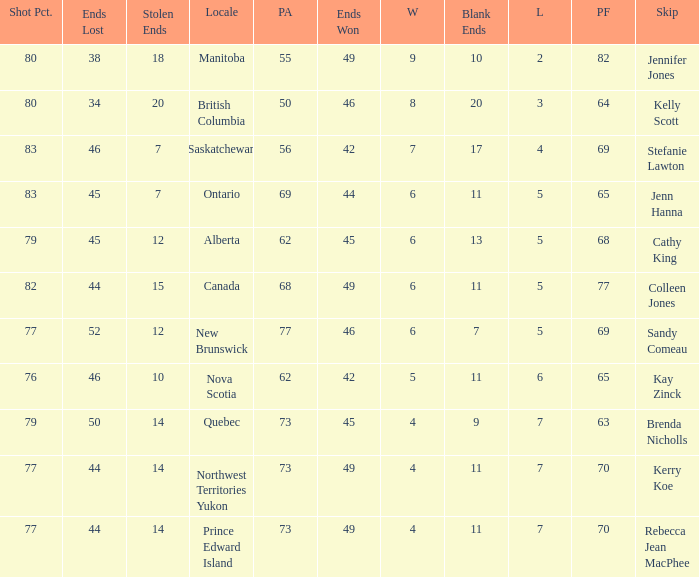Could you help me parse every detail presented in this table? {'header': ['Shot Pct.', 'Ends Lost', 'Stolen Ends', 'Locale', 'PA', 'Ends Won', 'W', 'Blank Ends', 'L', 'PF', 'Skip'], 'rows': [['80', '38', '18', 'Manitoba', '55', '49', '9', '10', '2', '82', 'Jennifer Jones'], ['80', '34', '20', 'British Columbia', '50', '46', '8', '20', '3', '64', 'Kelly Scott'], ['83', '46', '7', 'Saskatchewan', '56', '42', '7', '17', '4', '69', 'Stefanie Lawton'], ['83', '45', '7', 'Ontario', '69', '44', '6', '11', '5', '65', 'Jenn Hanna'], ['79', '45', '12', 'Alberta', '62', '45', '6', '13', '5', '68', 'Cathy King'], ['82', '44', '15', 'Canada', '68', '49', '6', '11', '5', '77', 'Colleen Jones'], ['77', '52', '12', 'New Brunswick', '77', '46', '6', '7', '5', '69', 'Sandy Comeau'], ['76', '46', '10', 'Nova Scotia', '62', '42', '5', '11', '6', '65', 'Kay Zinck'], ['79', '50', '14', 'Quebec', '73', '45', '4', '9', '7', '63', 'Brenda Nicholls'], ['77', '44', '14', 'Northwest Territories Yukon', '73', '49', '4', '11', '7', '70', 'Kerry Koe'], ['77', '44', '14', 'Prince Edward Island', '73', '49', '4', '11', '7', '70', 'Rebecca Jean MacPhee']]} What is the PA when the skip is Colleen Jones? 68.0. 